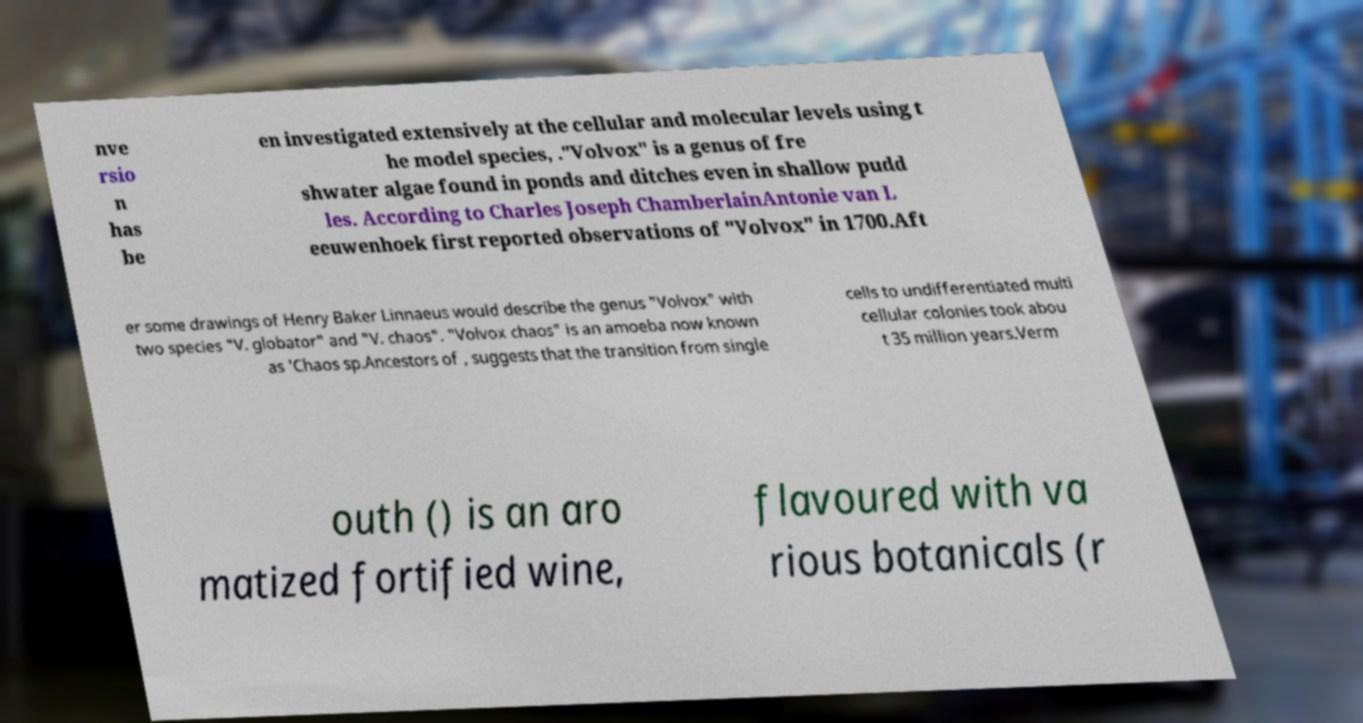I need the written content from this picture converted into text. Can you do that? nve rsio n has be en investigated extensively at the cellular and molecular levels using t he model species, ."Volvox" is a genus of fre shwater algae found in ponds and ditches even in shallow pudd les. According to Charles Joseph ChamberlainAntonie van L eeuwenhoek first reported observations of "Volvox" in 1700.Aft er some drawings of Henry Baker Linnaeus would describe the genus "Volvox" with two species "V. globator" and "V. chaos". "Volvox chaos" is an amoeba now known as 'Chaos sp.Ancestors of , suggests that the transition from single cells to undifferentiated multi cellular colonies took abou t 35 million years.Verm outh () is an aro matized fortified wine, flavoured with va rious botanicals (r 